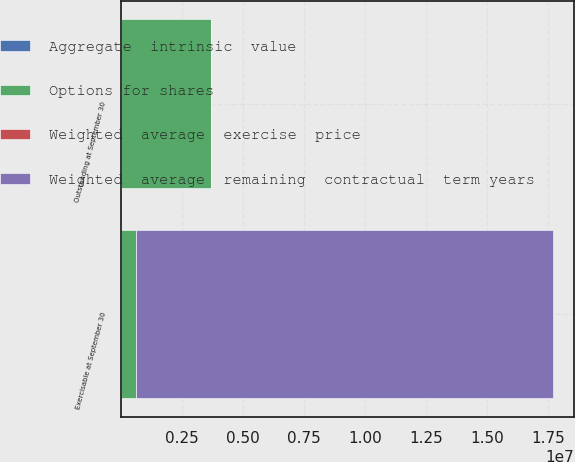Convert chart to OTSL. <chart><loc_0><loc_0><loc_500><loc_500><stacked_bar_chart><ecel><fcel>Outstanding at September 30<fcel>Exercisable at September 30<nl><fcel>Options for shares<fcel>3.71047e+06<fcel>639607<nl><fcel>Aggregate  intrinsic  value<fcel>44.88<fcel>31.54<nl><fcel>Weighted  average  exercise  price<fcel>3.5<fcel>1.35<nl><fcel>Weighted  average  remaining  contractual  term years<fcel>44.88<fcel>1.7058e+07<nl></chart> 